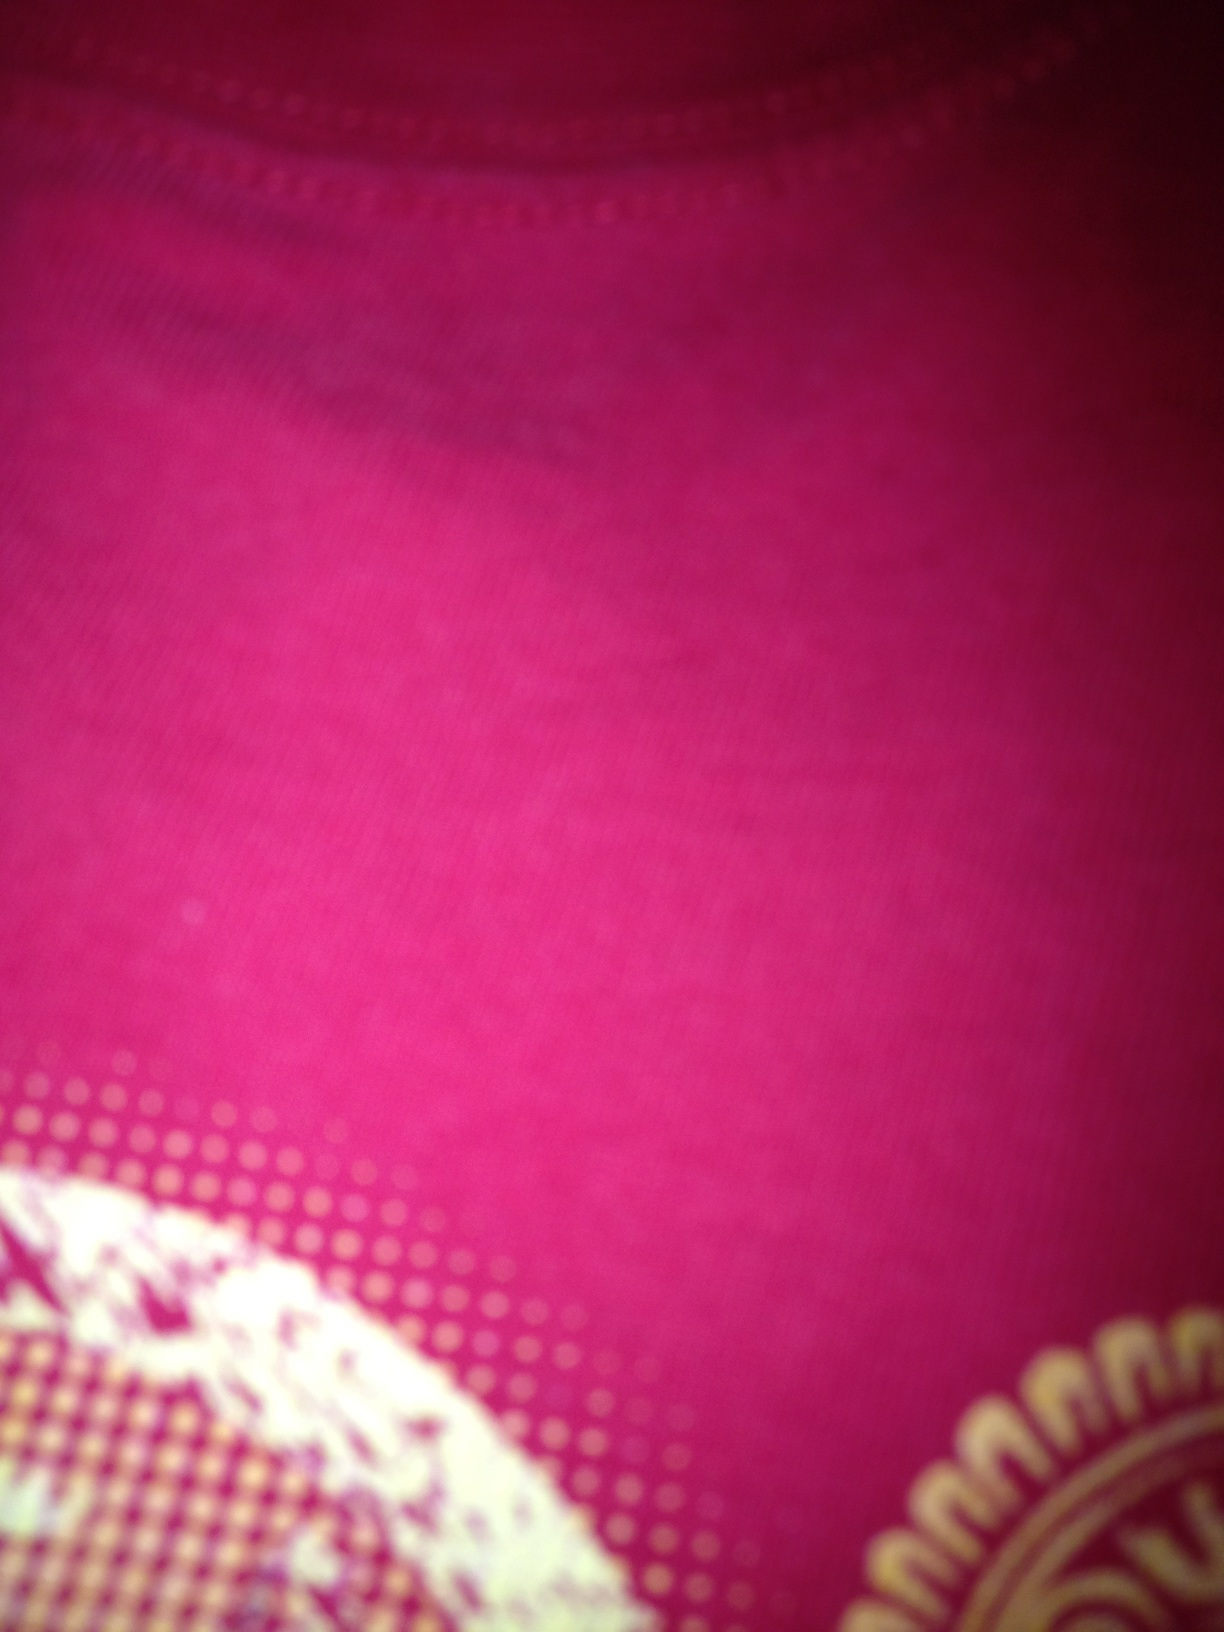Can you tell me what material this might be? The fabric in the image appears to be a kind of textile with a smooth texture, possibly cotton or a cotton blend, which is commonly used in clothing due to its comfort and breathability. 